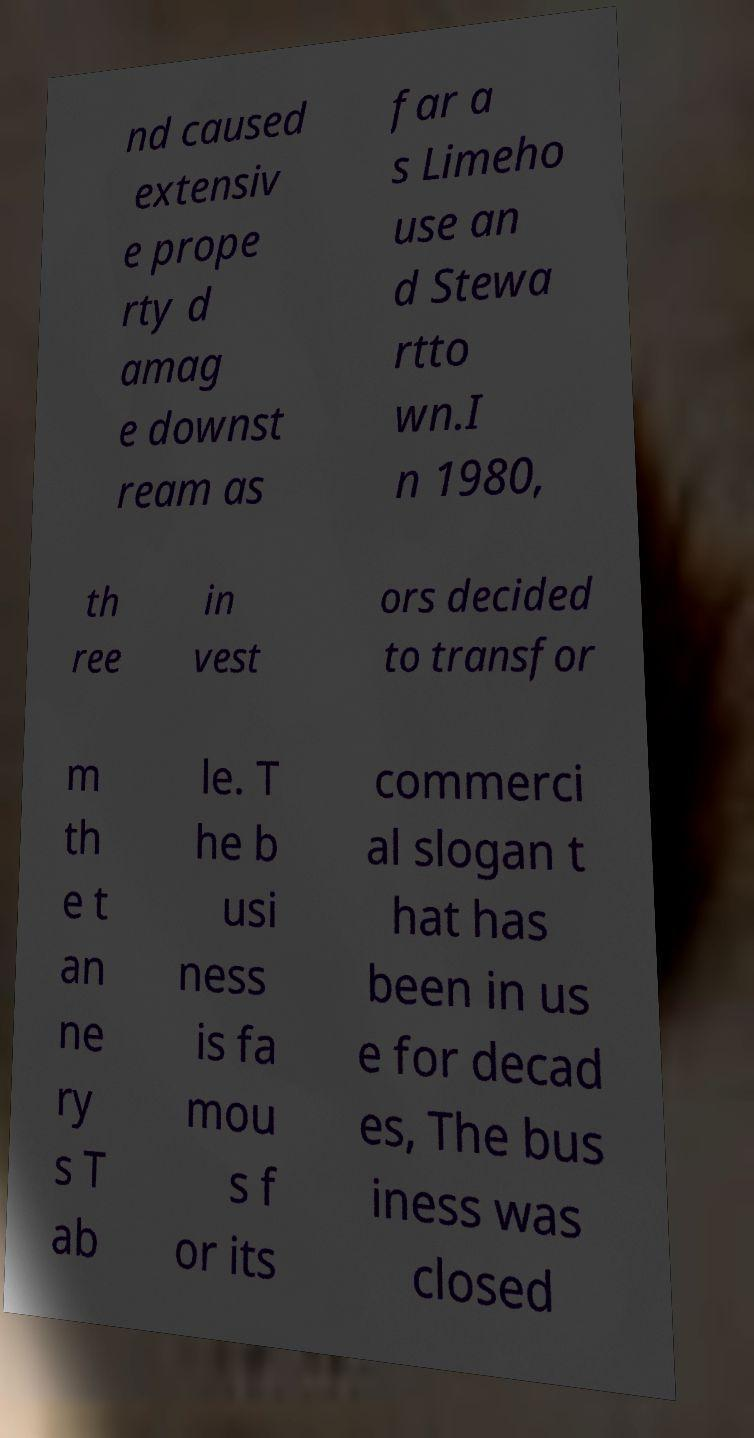Could you extract and type out the text from this image? nd caused extensiv e prope rty d amag e downst ream as far a s Limeho use an d Stewa rtto wn.I n 1980, th ree in vest ors decided to transfor m th e t an ne ry s T ab le. T he b usi ness is fa mou s f or its commerci al slogan t hat has been in us e for decad es, The bus iness was closed 